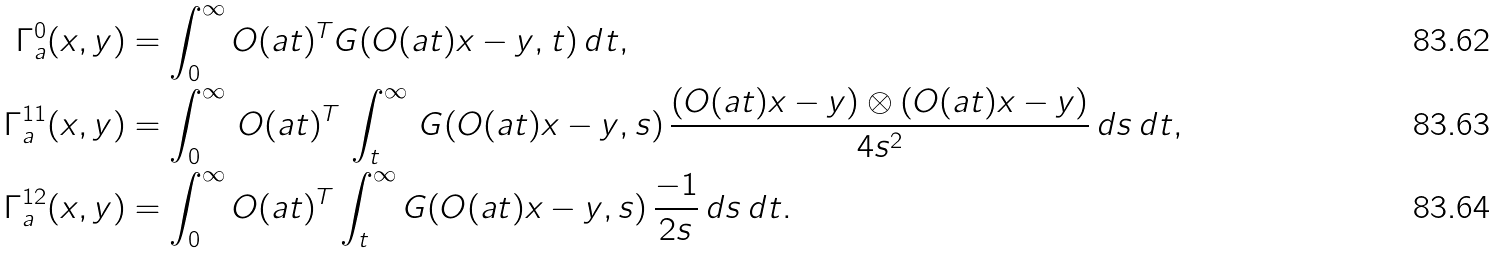Convert formula to latex. <formula><loc_0><loc_0><loc_500><loc_500>\Gamma _ { a } ^ { 0 } ( x , y ) & = \int _ { 0 } ^ { \infty } O ( a t ) ^ { T } G ( O ( a t ) x - y , t ) \, d t , \\ \Gamma _ { a } ^ { 1 1 } ( x , y ) & = \int _ { 0 } ^ { \infty } \, O ( a t ) ^ { T } \, \int _ { t } ^ { \infty } \, G ( O ( a t ) x - y , s ) \, \frac { ( O ( a t ) x - y ) \otimes ( O ( a t ) x - y ) } { 4 s ^ { 2 } } \, d s \, d t , \\ \Gamma _ { a } ^ { 1 2 } ( x , y ) & = \int _ { 0 } ^ { \infty } O ( a t ) ^ { T } \int _ { t } ^ { \infty } G ( O ( a t ) x - y , s ) \, \frac { - 1 } { 2 s } \, d s \, d t .</formula> 